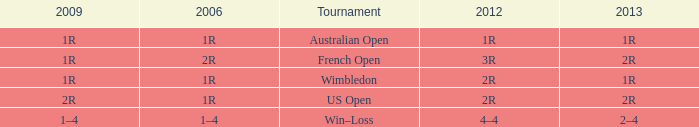What is the Tournament when the 2013 is 2r, and a 2006 is 1r? US Open. 